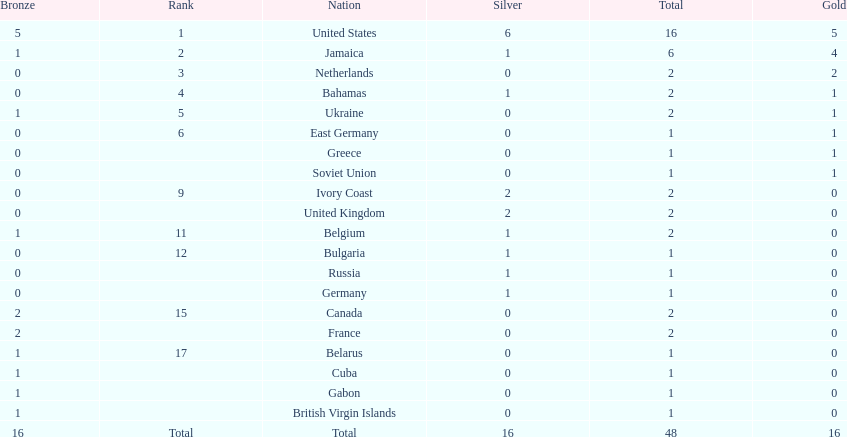How many nations achieved no gold medals? 12. 